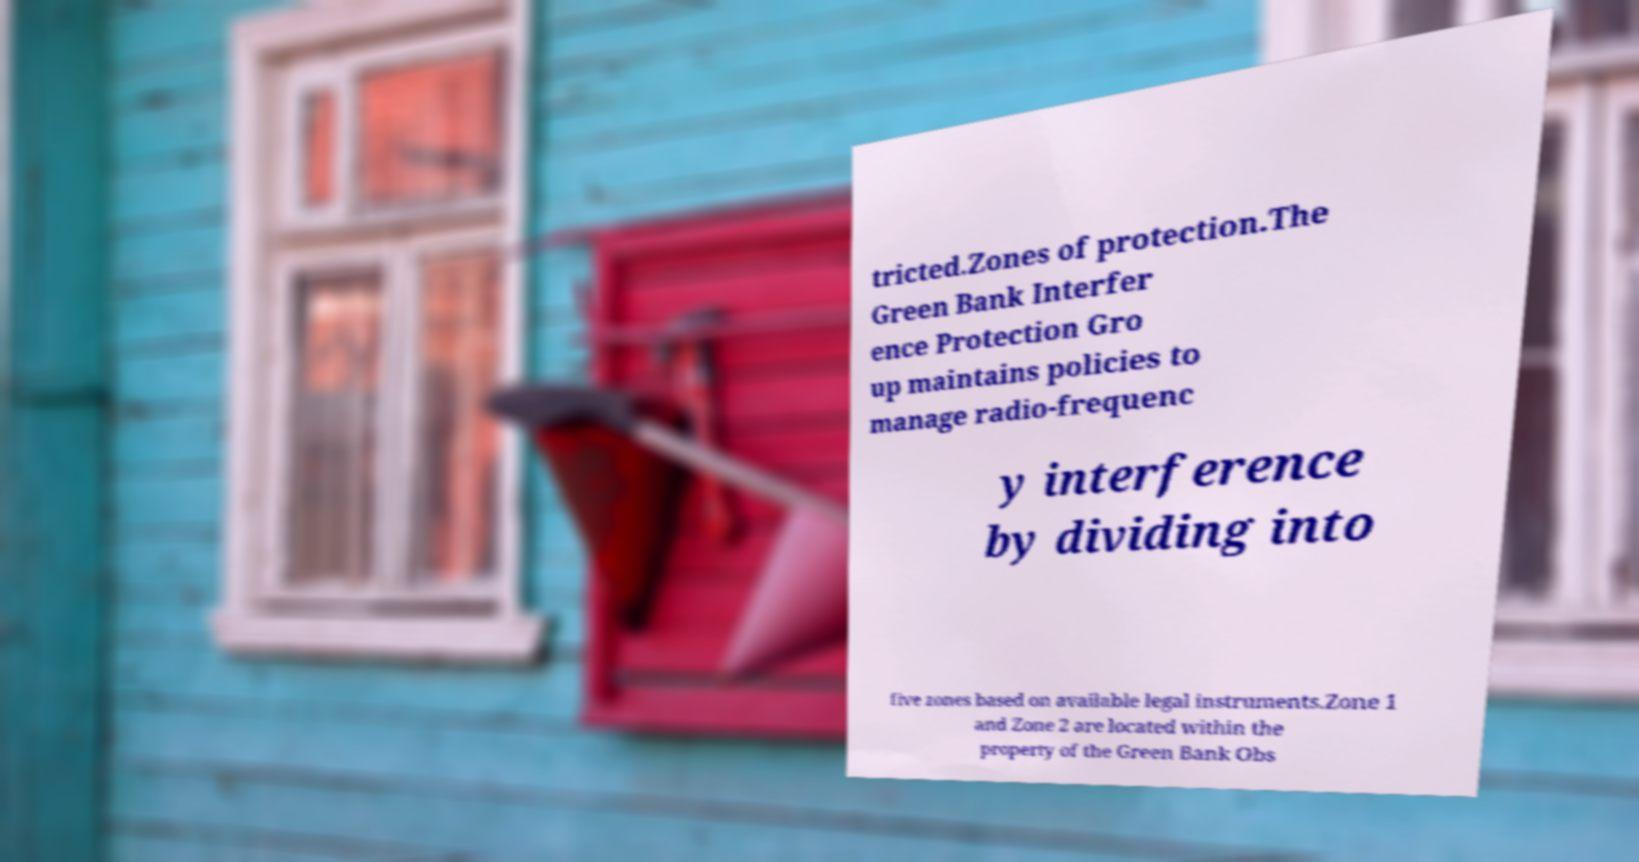Could you assist in decoding the text presented in this image and type it out clearly? tricted.Zones of protection.The Green Bank Interfer ence Protection Gro up maintains policies to manage radio-frequenc y interference by dividing into five zones based on available legal instruments.Zone 1 and Zone 2 are located within the property of the Green Bank Obs 